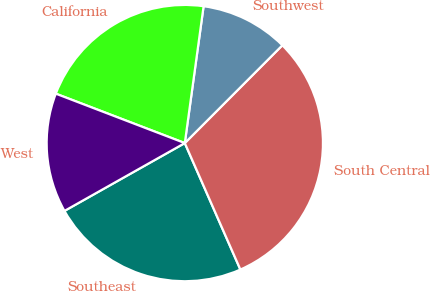<chart> <loc_0><loc_0><loc_500><loc_500><pie_chart><fcel>Southeast<fcel>South Central<fcel>Southwest<fcel>California<fcel>West<nl><fcel>23.42%<fcel>30.93%<fcel>10.31%<fcel>21.35%<fcel>13.99%<nl></chart> 